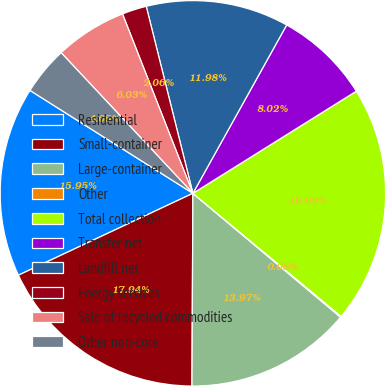Convert chart to OTSL. <chart><loc_0><loc_0><loc_500><loc_500><pie_chart><fcel>Residential<fcel>Small-container<fcel>Large-container<fcel>Other<fcel>Total collection<fcel>Transfer net<fcel>Landfill net<fcel>Energy services<fcel>Sale of recycled commodities<fcel>Other non-core<nl><fcel>15.95%<fcel>17.94%<fcel>13.97%<fcel>0.08%<fcel>19.92%<fcel>8.02%<fcel>11.98%<fcel>2.06%<fcel>6.03%<fcel>4.05%<nl></chart> 